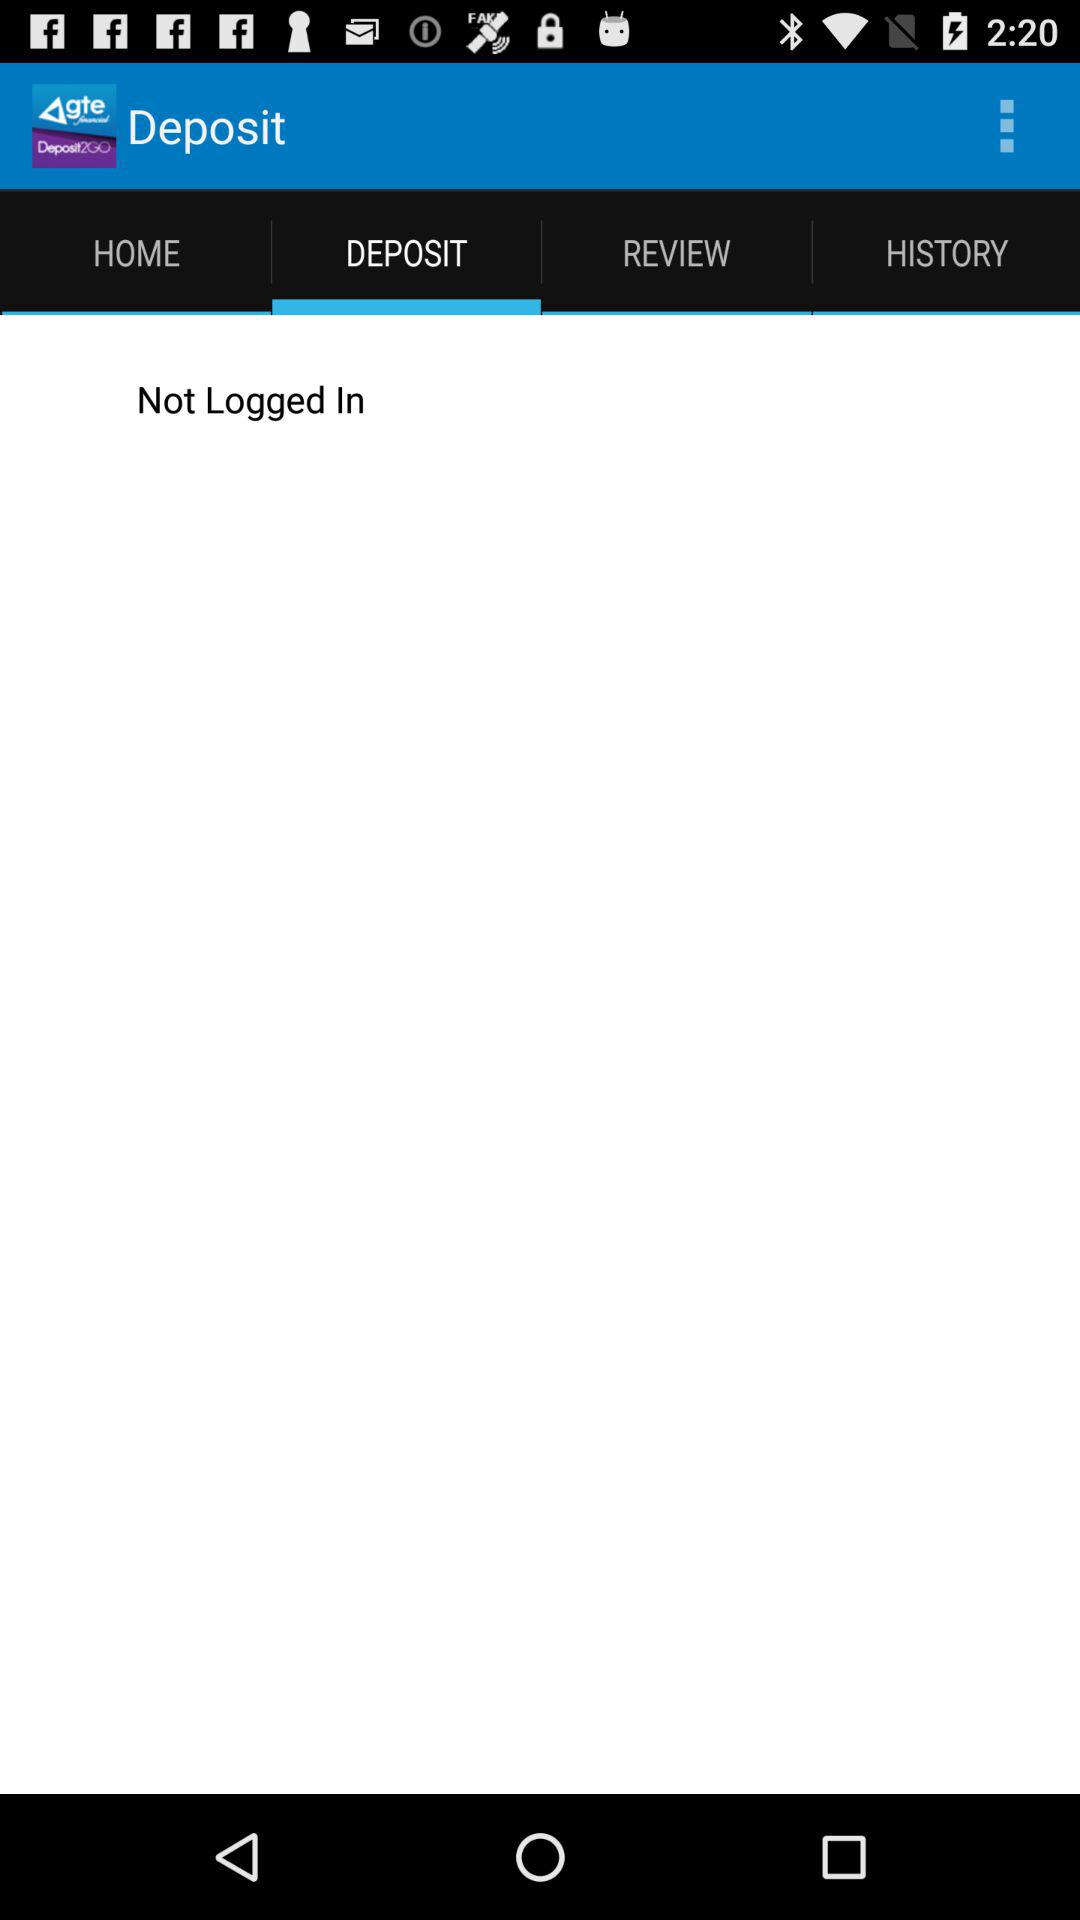Which tab is selected? The tab "DEPOSIT" is selected. 